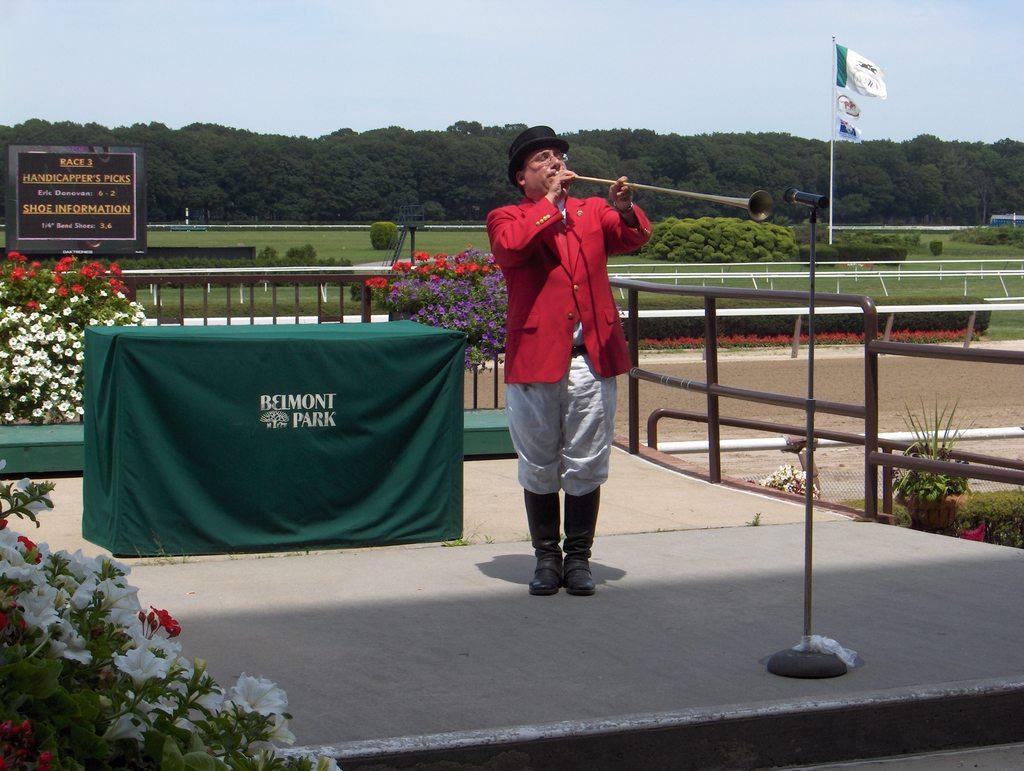Describe this image in one or two sentences. In this picture I can see the stage in front on which there is a man standing and holding a musical instrument and in front of him I can see a tripod on which there is a mic. Behind him I can see a table on which there is green color cloth and I see 2 words written. On the left side of this image I can see the plants on which there are flowers. In the background I can see the plants, few more flowers, a board on which there are words written, 3 flags, number of trees and the sky. On the right side of this picture I can see the railing. 